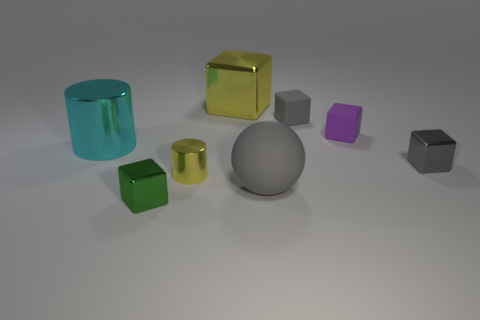Do the rubber object in front of the gray shiny cube and the tiny metallic cube that is behind the small green shiny block have the same color?
Make the answer very short. Yes. What size is the thing that is the same color as the small metallic cylinder?
Keep it short and to the point. Large. There is a small cylinder that is the same color as the large cube; what is it made of?
Your answer should be compact. Metal. Are there more yellow objects behind the tiny purple thing than brown shiny balls?
Your answer should be compact. Yes. There is a large metallic object that is in front of the gray matte object behind the tiny gray shiny block that is behind the gray rubber ball; what shape is it?
Keep it short and to the point. Cylinder. Does the yellow shiny object that is to the left of the yellow metallic cube have the same shape as the metallic thing that is on the left side of the green metallic object?
Make the answer very short. Yes. What number of balls are either large brown metal objects or small gray objects?
Ensure brevity in your answer.  0. Do the small yellow object and the tiny purple block have the same material?
Provide a succinct answer. No. How many other things are the same color as the tiny cylinder?
Your answer should be compact. 1. There is a yellow object behind the small yellow cylinder; what is its shape?
Offer a very short reply. Cube. 